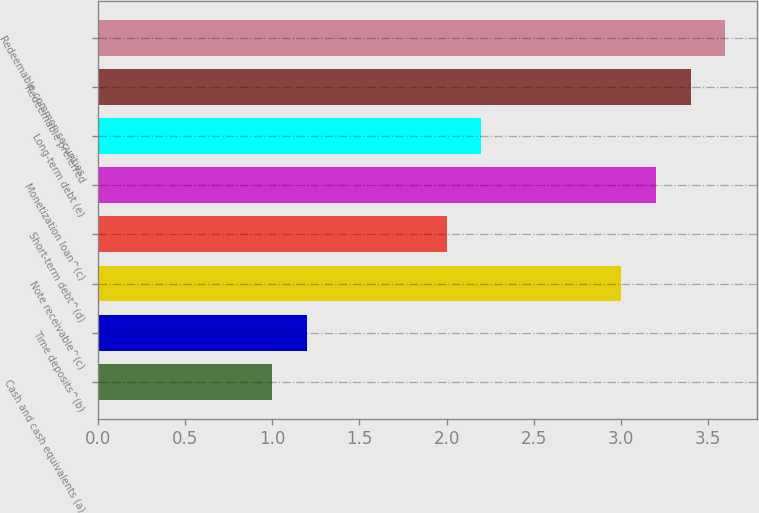<chart> <loc_0><loc_0><loc_500><loc_500><bar_chart><fcel>Cash and cash equivalents (a)<fcel>Time deposits^(b)<fcel>Note receivable^(c)<fcel>Short-term debt^(d)<fcel>Monetization loan^(c)<fcel>Long-term debt (e)<fcel>Redeemable preferred<fcel>Redeemable common securities<nl><fcel>1<fcel>1.2<fcel>3<fcel>2<fcel>3.2<fcel>2.2<fcel>3.4<fcel>3.6<nl></chart> 